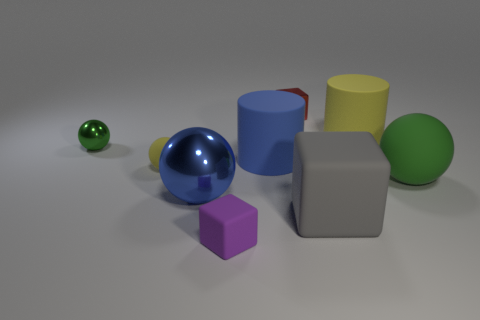Subtract all small blocks. How many blocks are left? 1 Add 6 large blue rubber cylinders. How many large blue rubber cylinders are left? 7 Add 9 brown rubber cylinders. How many brown rubber cylinders exist? 9 Add 1 big cyan objects. How many objects exist? 10 Subtract all yellow cylinders. How many cylinders are left? 1 Subtract 0 blue cubes. How many objects are left? 9 Subtract all spheres. How many objects are left? 5 Subtract 3 cubes. How many cubes are left? 0 Subtract all cyan cylinders. Subtract all green spheres. How many cylinders are left? 2 Subtract all brown blocks. How many red cylinders are left? 0 